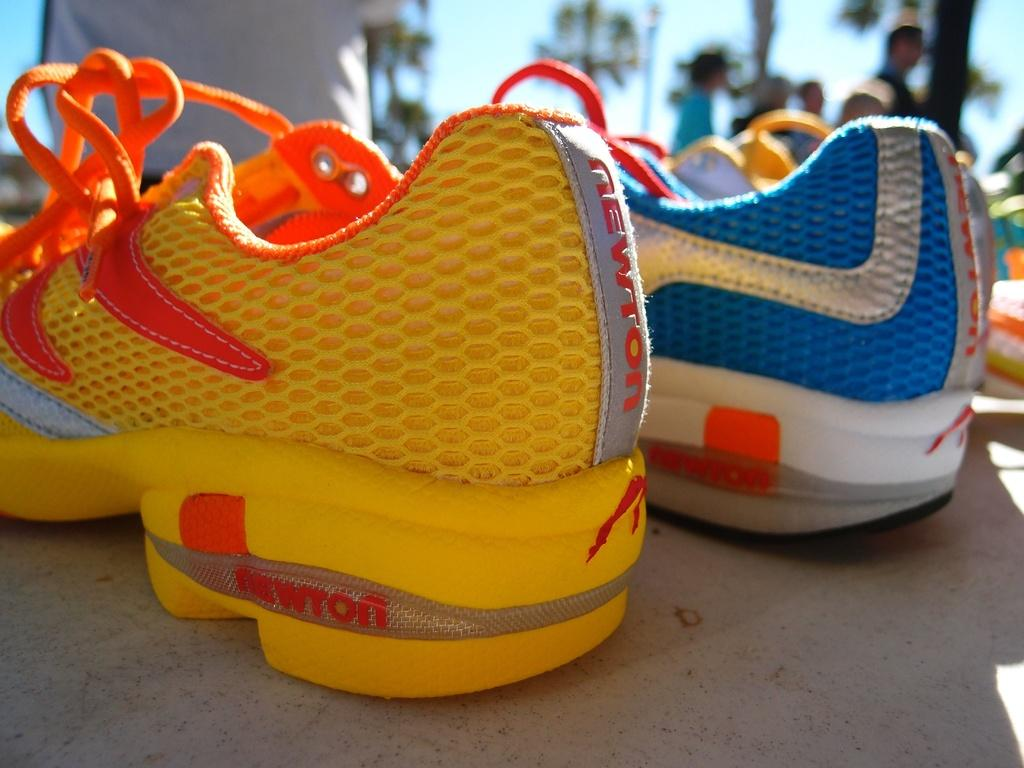What objects are present in the image? There are shoes in the image. What can be seen in the background of the image? There are trees, people, and the sky visible in the background of the image. What type of nut is being used to start a fire in the image? There is no nut or fire present in the image; it features shoes and a background with trees, people, and the sky. 